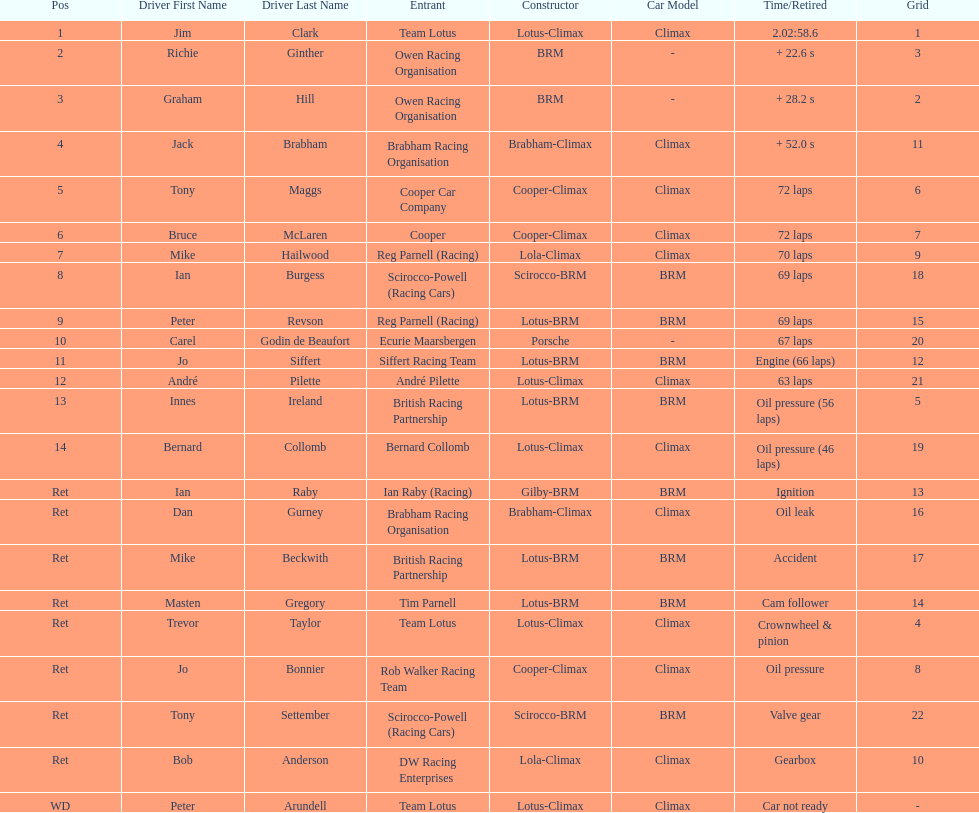What country had the least number of drivers, germany or the uk? Germany. 